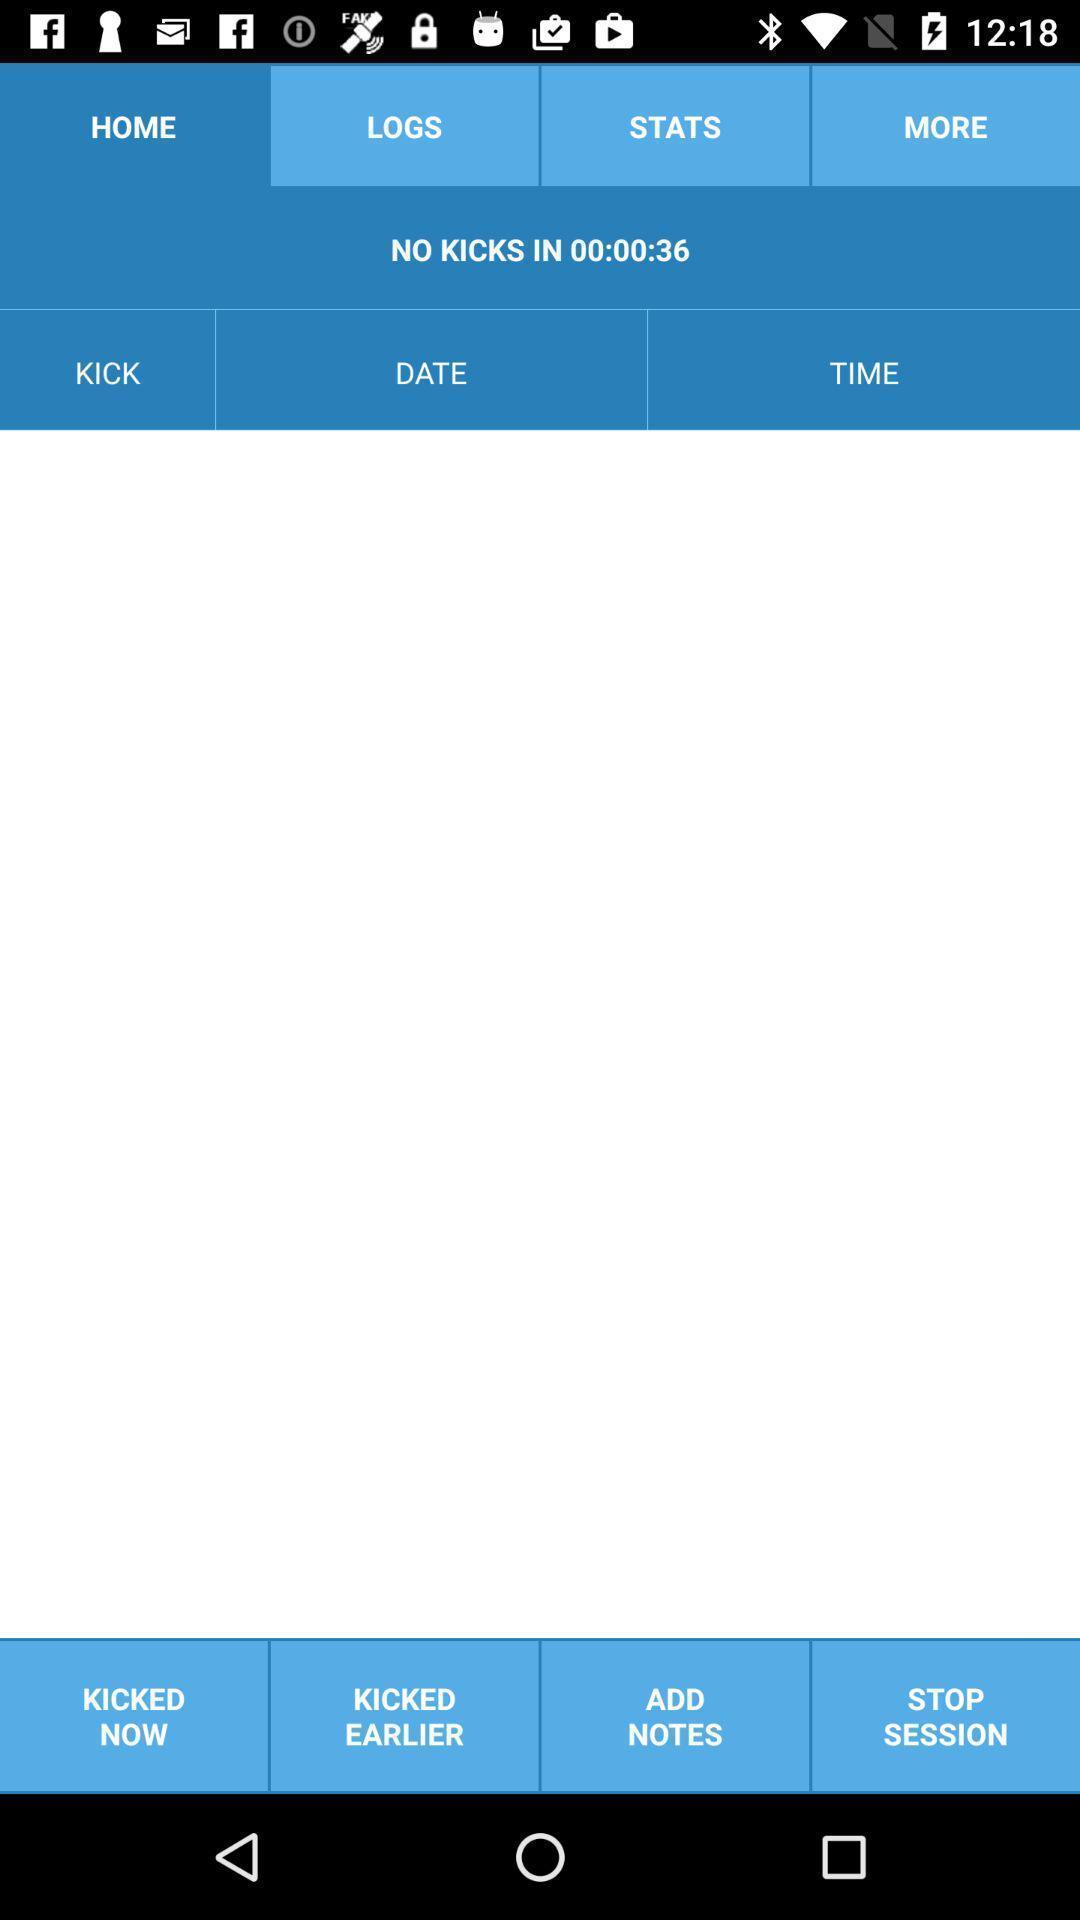What details can you identify in this image? Screen shows about pregnancy flutters of baby kicking. 